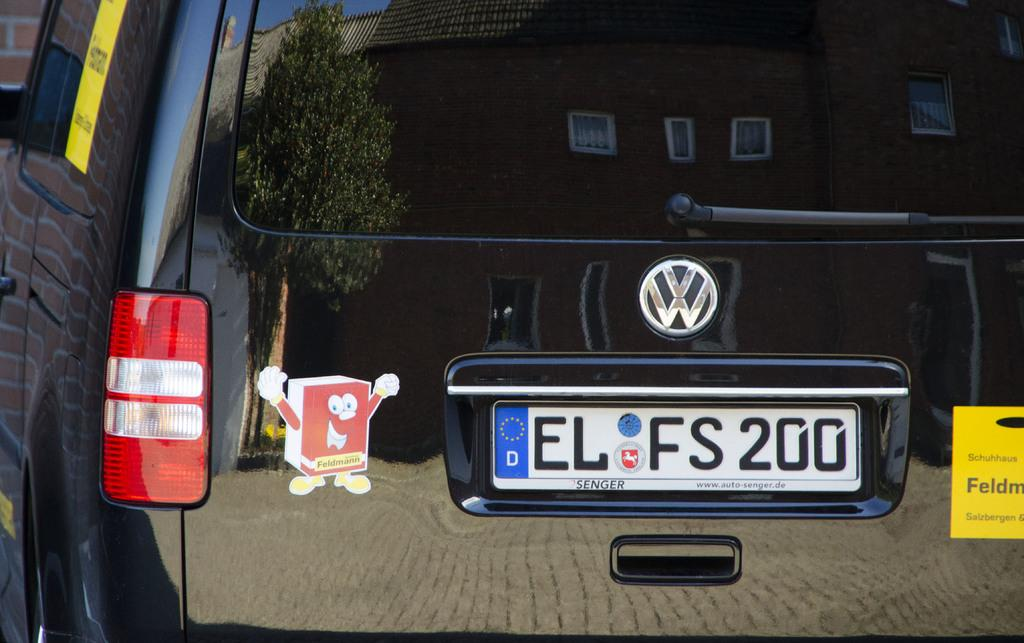<image>
Offer a succinct explanation of the picture presented. A Volkswagon car has a license plate that says "EL FS 200" 